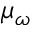Convert formula to latex. <formula><loc_0><loc_0><loc_500><loc_500>\mu _ { \omega }</formula> 